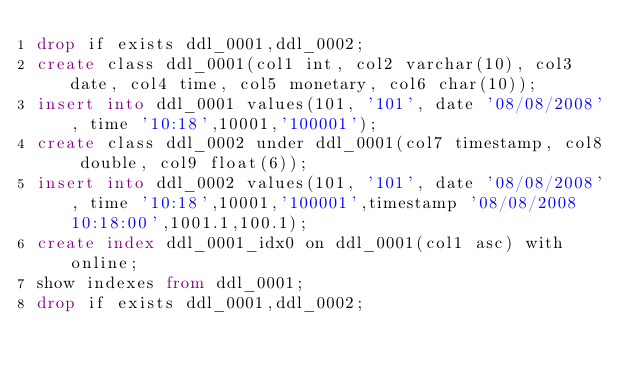<code> <loc_0><loc_0><loc_500><loc_500><_SQL_>drop if exists ddl_0001,ddl_0002;
create class ddl_0001(col1 int, col2 varchar(10), col3 date, col4 time, col5 monetary, col6 char(10));
insert into ddl_0001 values(101, '101', date '08/08/2008', time '10:18',10001,'100001');
create class ddl_0002 under ddl_0001(col7 timestamp, col8 double, col9 float(6));
insert into ddl_0002 values(101, '101', date '08/08/2008', time '10:18',10001,'100001',timestamp '08/08/2008 10:18:00',1001.1,100.1);
create index ddl_0001_idx0 on ddl_0001(col1 asc) with online;
show indexes from ddl_0001;
drop if exists ddl_0001,ddl_0002;
</code> 